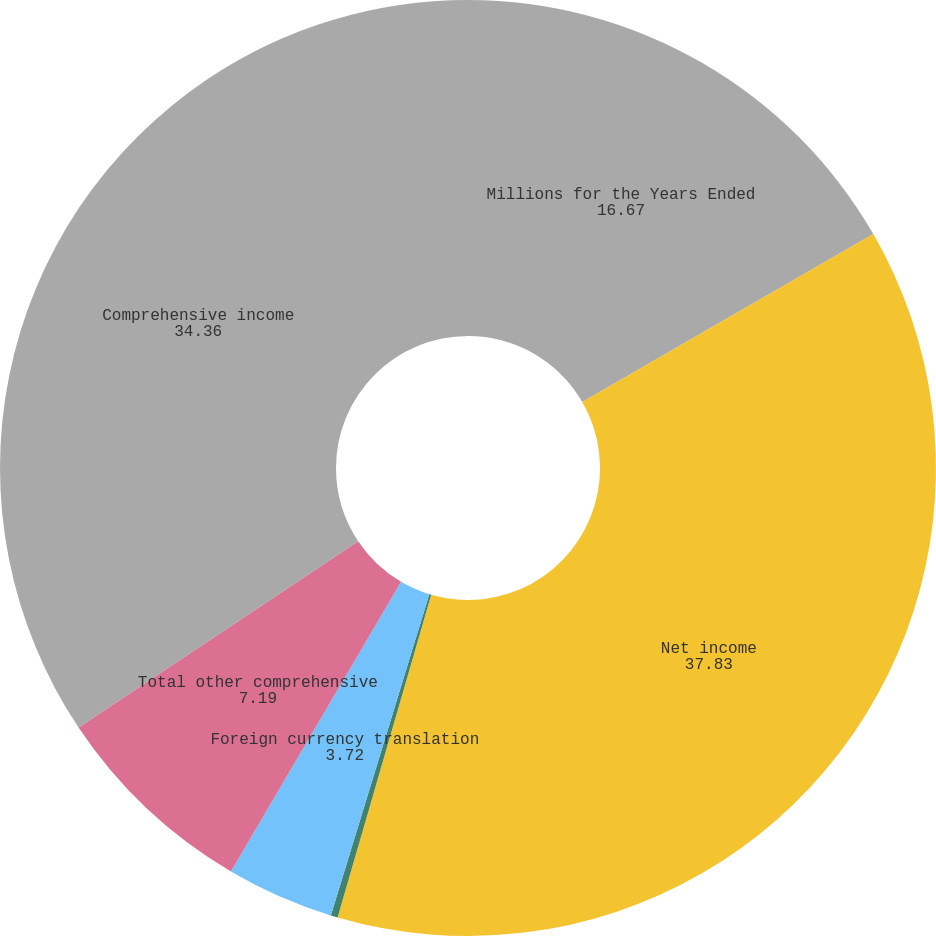Convert chart. <chart><loc_0><loc_0><loc_500><loc_500><pie_chart><fcel>Millions for the Years Ended<fcel>Net income<fcel>Defined benefit plans<fcel>Foreign currency translation<fcel>Total other comprehensive<fcel>Comprehensive income<nl><fcel>16.67%<fcel>37.83%<fcel>0.24%<fcel>3.72%<fcel>7.19%<fcel>34.36%<nl></chart> 